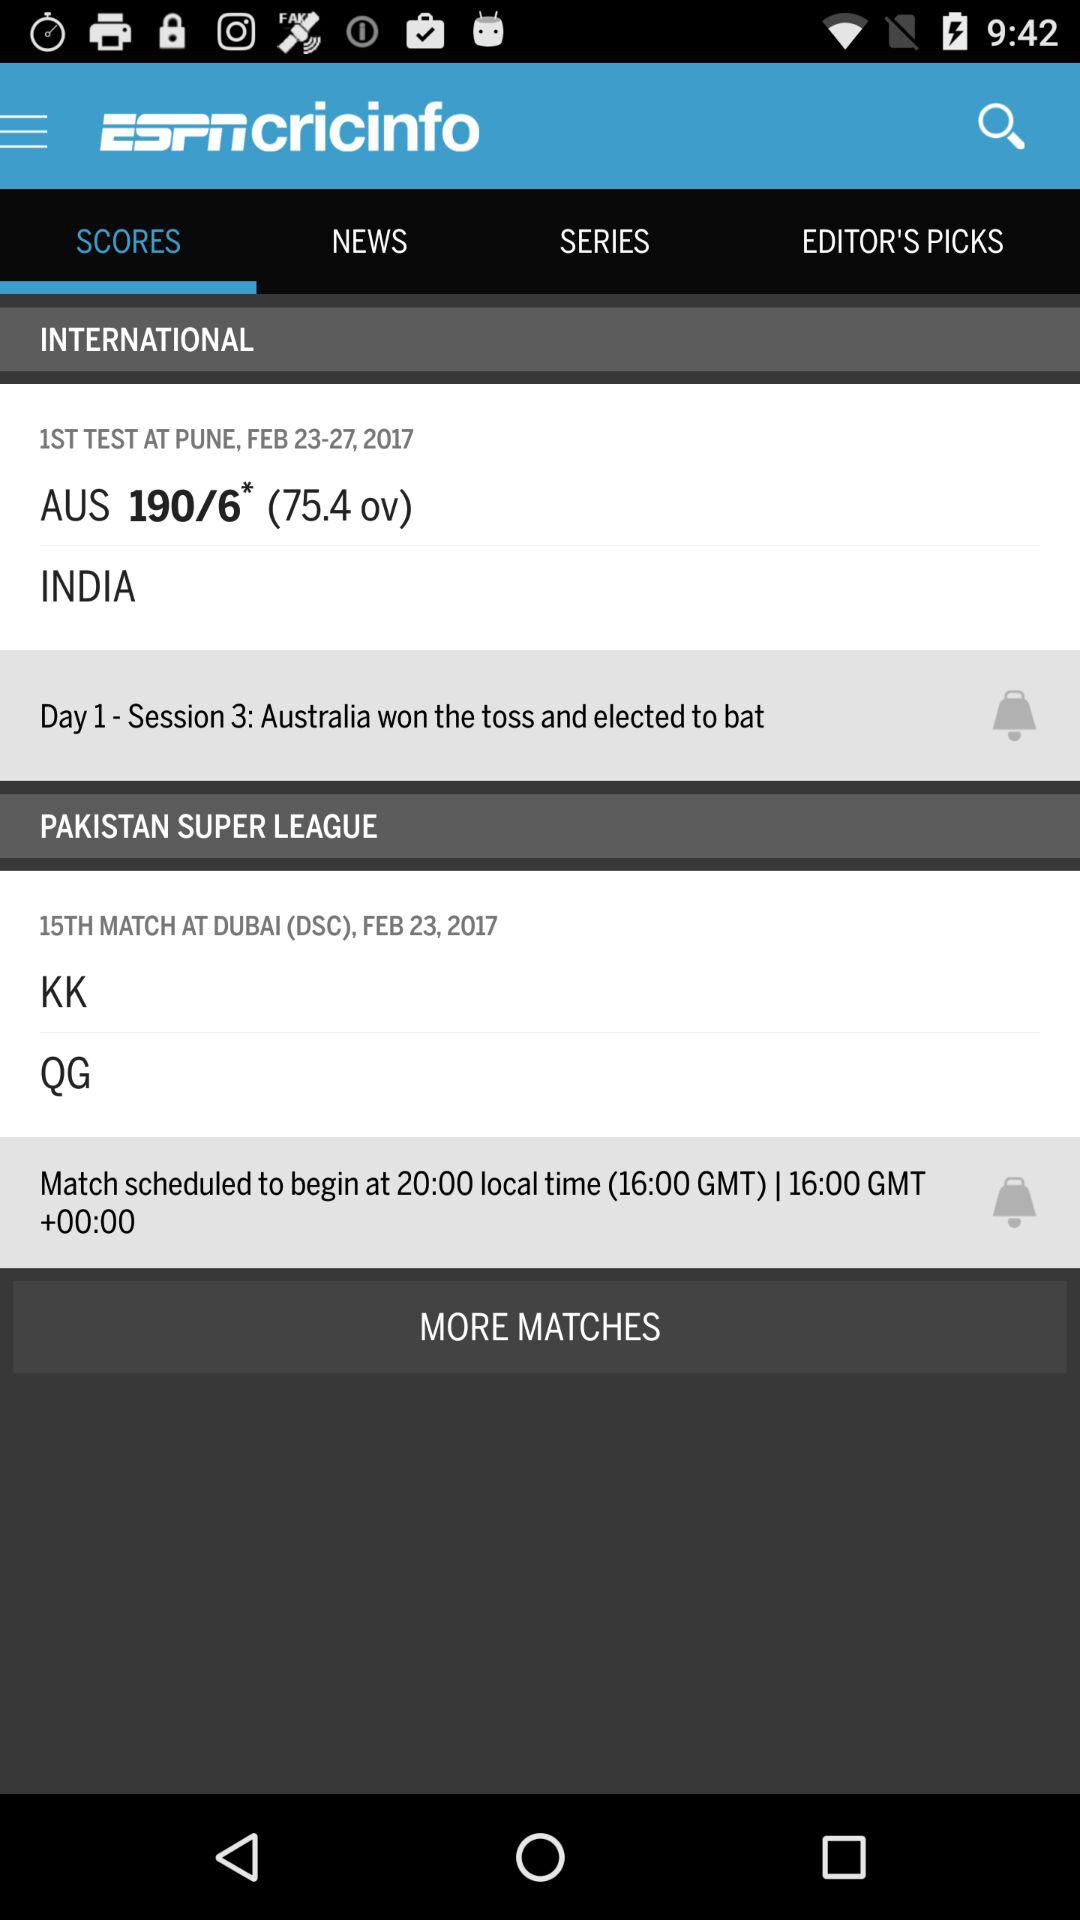What is the score of "Australia"? The score of "Australia" is 190/6. 